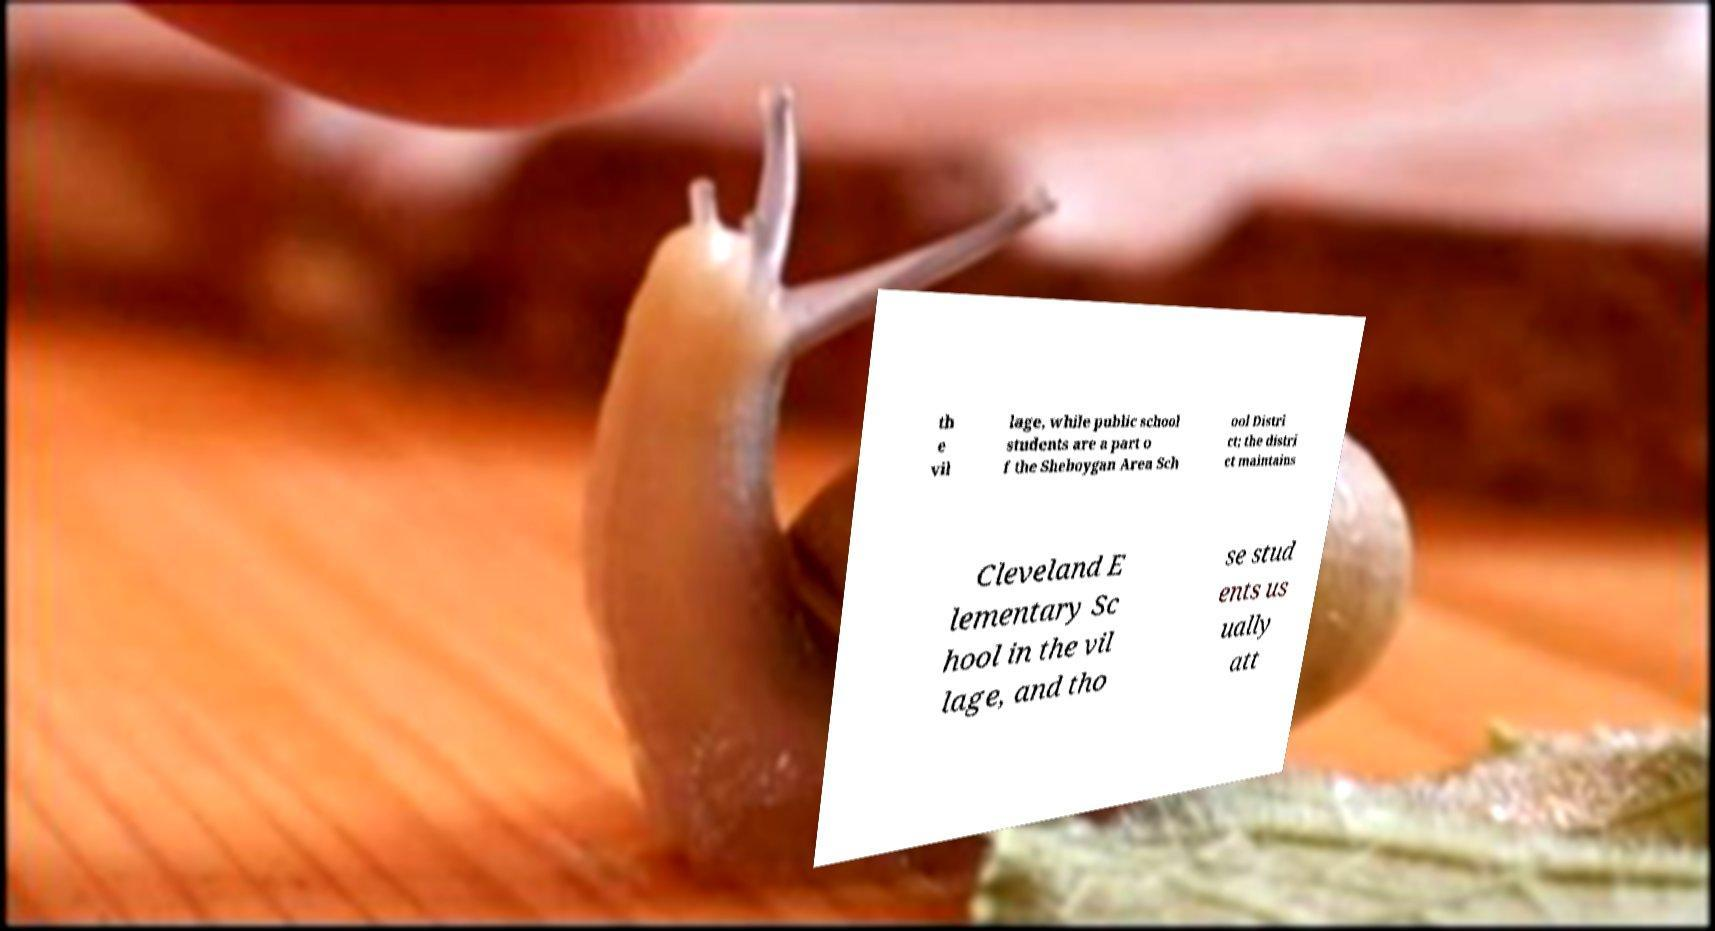Please identify and transcribe the text found in this image. th e vil lage, while public school students are a part o f the Sheboygan Area Sch ool Distri ct; the distri ct maintains Cleveland E lementary Sc hool in the vil lage, and tho se stud ents us ually att 